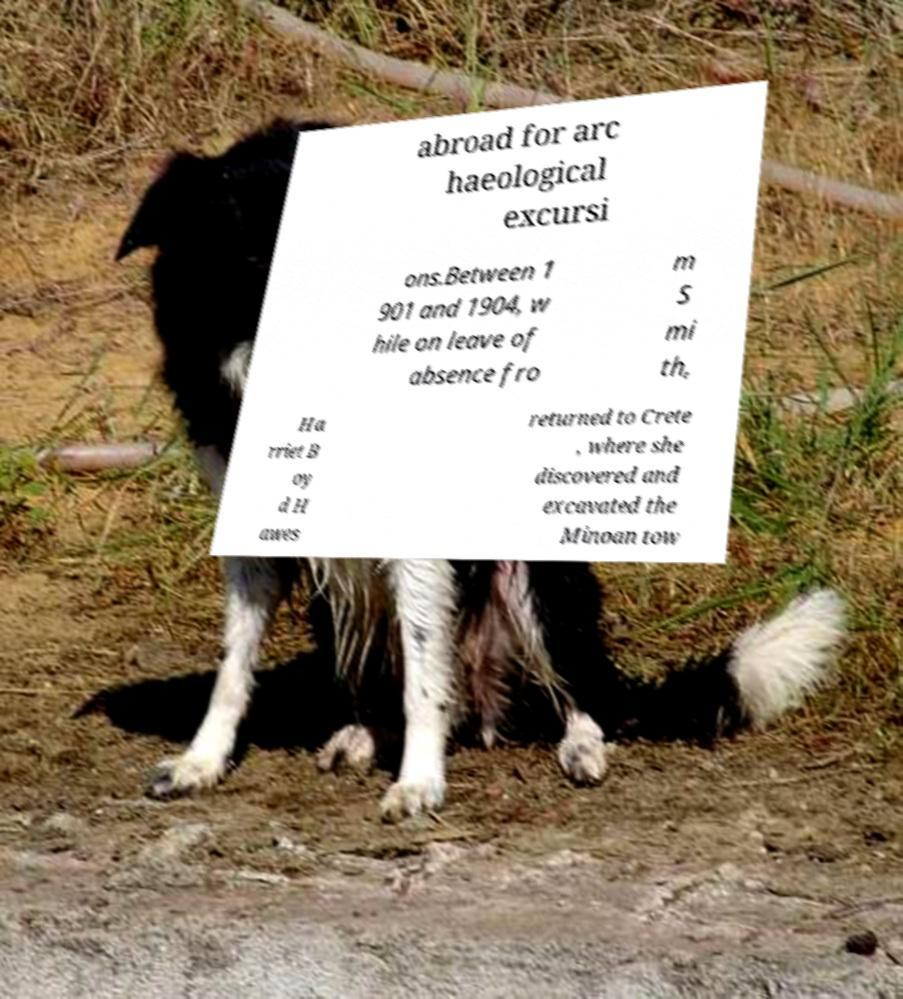Could you assist in decoding the text presented in this image and type it out clearly? abroad for arc haeological excursi ons.Between 1 901 and 1904, w hile on leave of absence fro m S mi th, Ha rriet B oy d H awes returned to Crete , where she discovered and excavated the Minoan tow 